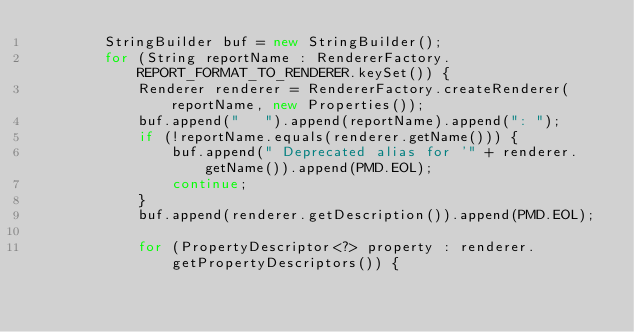<code> <loc_0><loc_0><loc_500><loc_500><_Java_>        StringBuilder buf = new StringBuilder();
        for (String reportName : RendererFactory.REPORT_FORMAT_TO_RENDERER.keySet()) {
            Renderer renderer = RendererFactory.createRenderer(reportName, new Properties());
            buf.append("   ").append(reportName).append(": ");
            if (!reportName.equals(renderer.getName())) {
                buf.append(" Deprecated alias for '" + renderer.getName()).append(PMD.EOL);
                continue;
            }
            buf.append(renderer.getDescription()).append(PMD.EOL);

            for (PropertyDescriptor<?> property : renderer.getPropertyDescriptors()) {</code> 